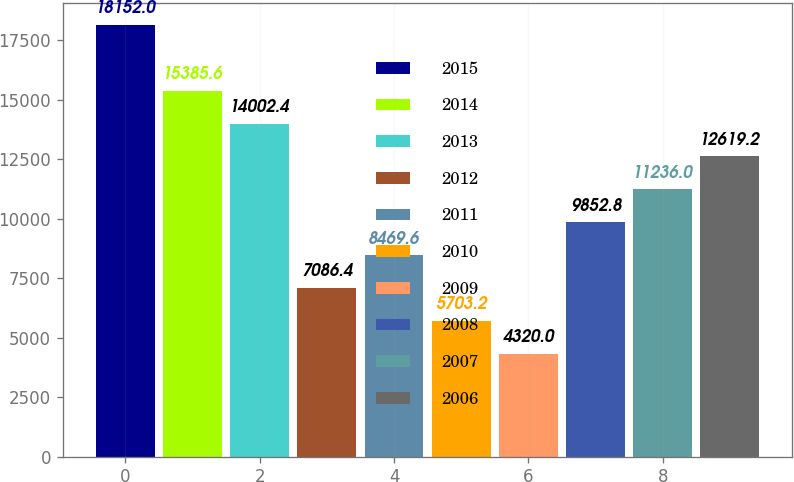<chart> <loc_0><loc_0><loc_500><loc_500><bar_chart><fcel>2015<fcel>2014<fcel>2013<fcel>2012<fcel>2011<fcel>2010<fcel>2009<fcel>2008<fcel>2007<fcel>2006<nl><fcel>18152<fcel>15385.6<fcel>14002.4<fcel>7086.4<fcel>8469.6<fcel>5703.2<fcel>4320<fcel>9852.8<fcel>11236<fcel>12619.2<nl></chart> 